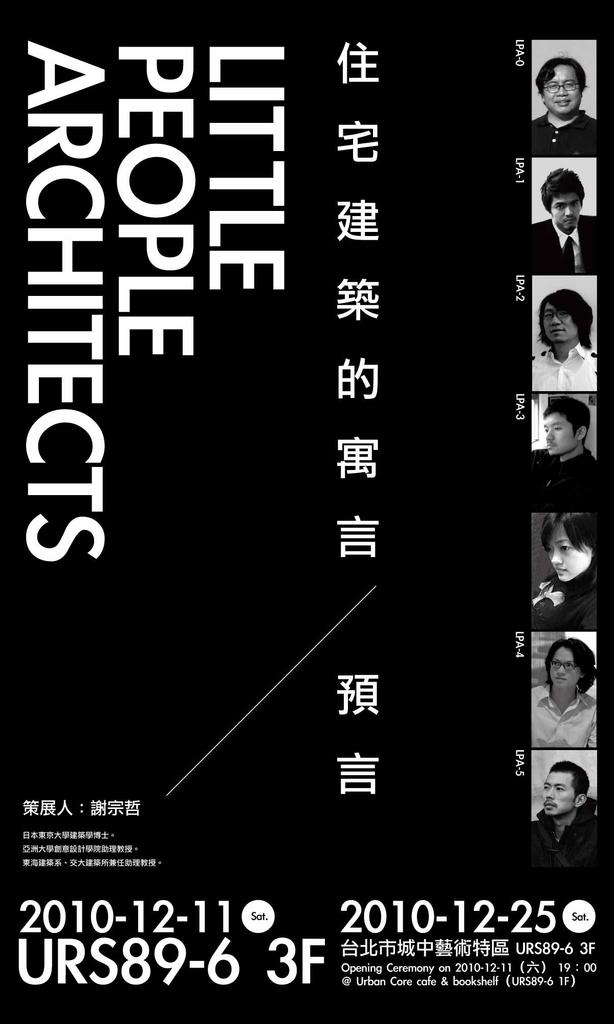<image>
Give a short and clear explanation of the subsequent image. A black poster is for "Little People Architects." 